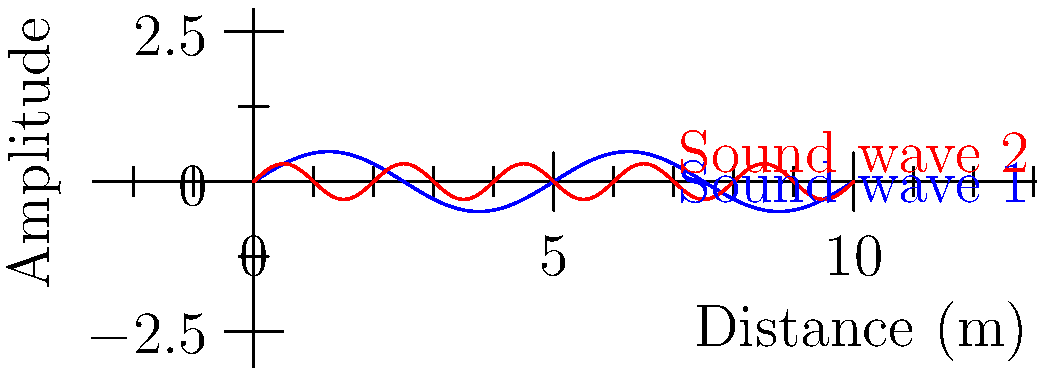During a political rally, two sound sources are used to amplify the speaker's voice. The graph shows the propagation of sound waves from these sources. If the blue wave represents the main speaker system and the red wave represents a secondary amplifier, how would you adjust the setup to minimize destructive interference and maximize sound clarity for the audience? To answer this question, let's analyze the sound waves step-by-step:

1. Wave characteristics:
   - Blue wave (main speaker): longer wavelength, higher amplitude
   - Red wave (secondary amplifier): shorter wavelength, lower amplitude

2. Interference:
   - Constructive interference occurs when waves are in phase
   - Destructive interference occurs when waves are out of phase

3. To minimize destructive interference:
   a) Adjust the phase: Ensure the peaks of both waves align
   b) Adjust the distance: Position the secondary amplifier so its waves reinforce the main waves

4. To maximize sound clarity:
   a) Reduce the amplitude of the secondary amplifier (red wave)
   b) Synchronize the frequencies of both sources

5. Practical solution:
   - Move the secondary amplifier closer to or farther from the audience to align its phase with the main speaker
   - Reduce the volume of the secondary amplifier
   - Use digital signal processing to synchronize the timing and frequency of both sources

6. Political consideration:
   - Ensure clear sound throughout the rally area for effective message delivery
   - Consider the acoustics of the venue to optimize speaker placement
Answer: Align wave phases, reduce secondary amplifier volume, and use digital synchronization. 